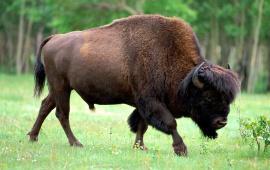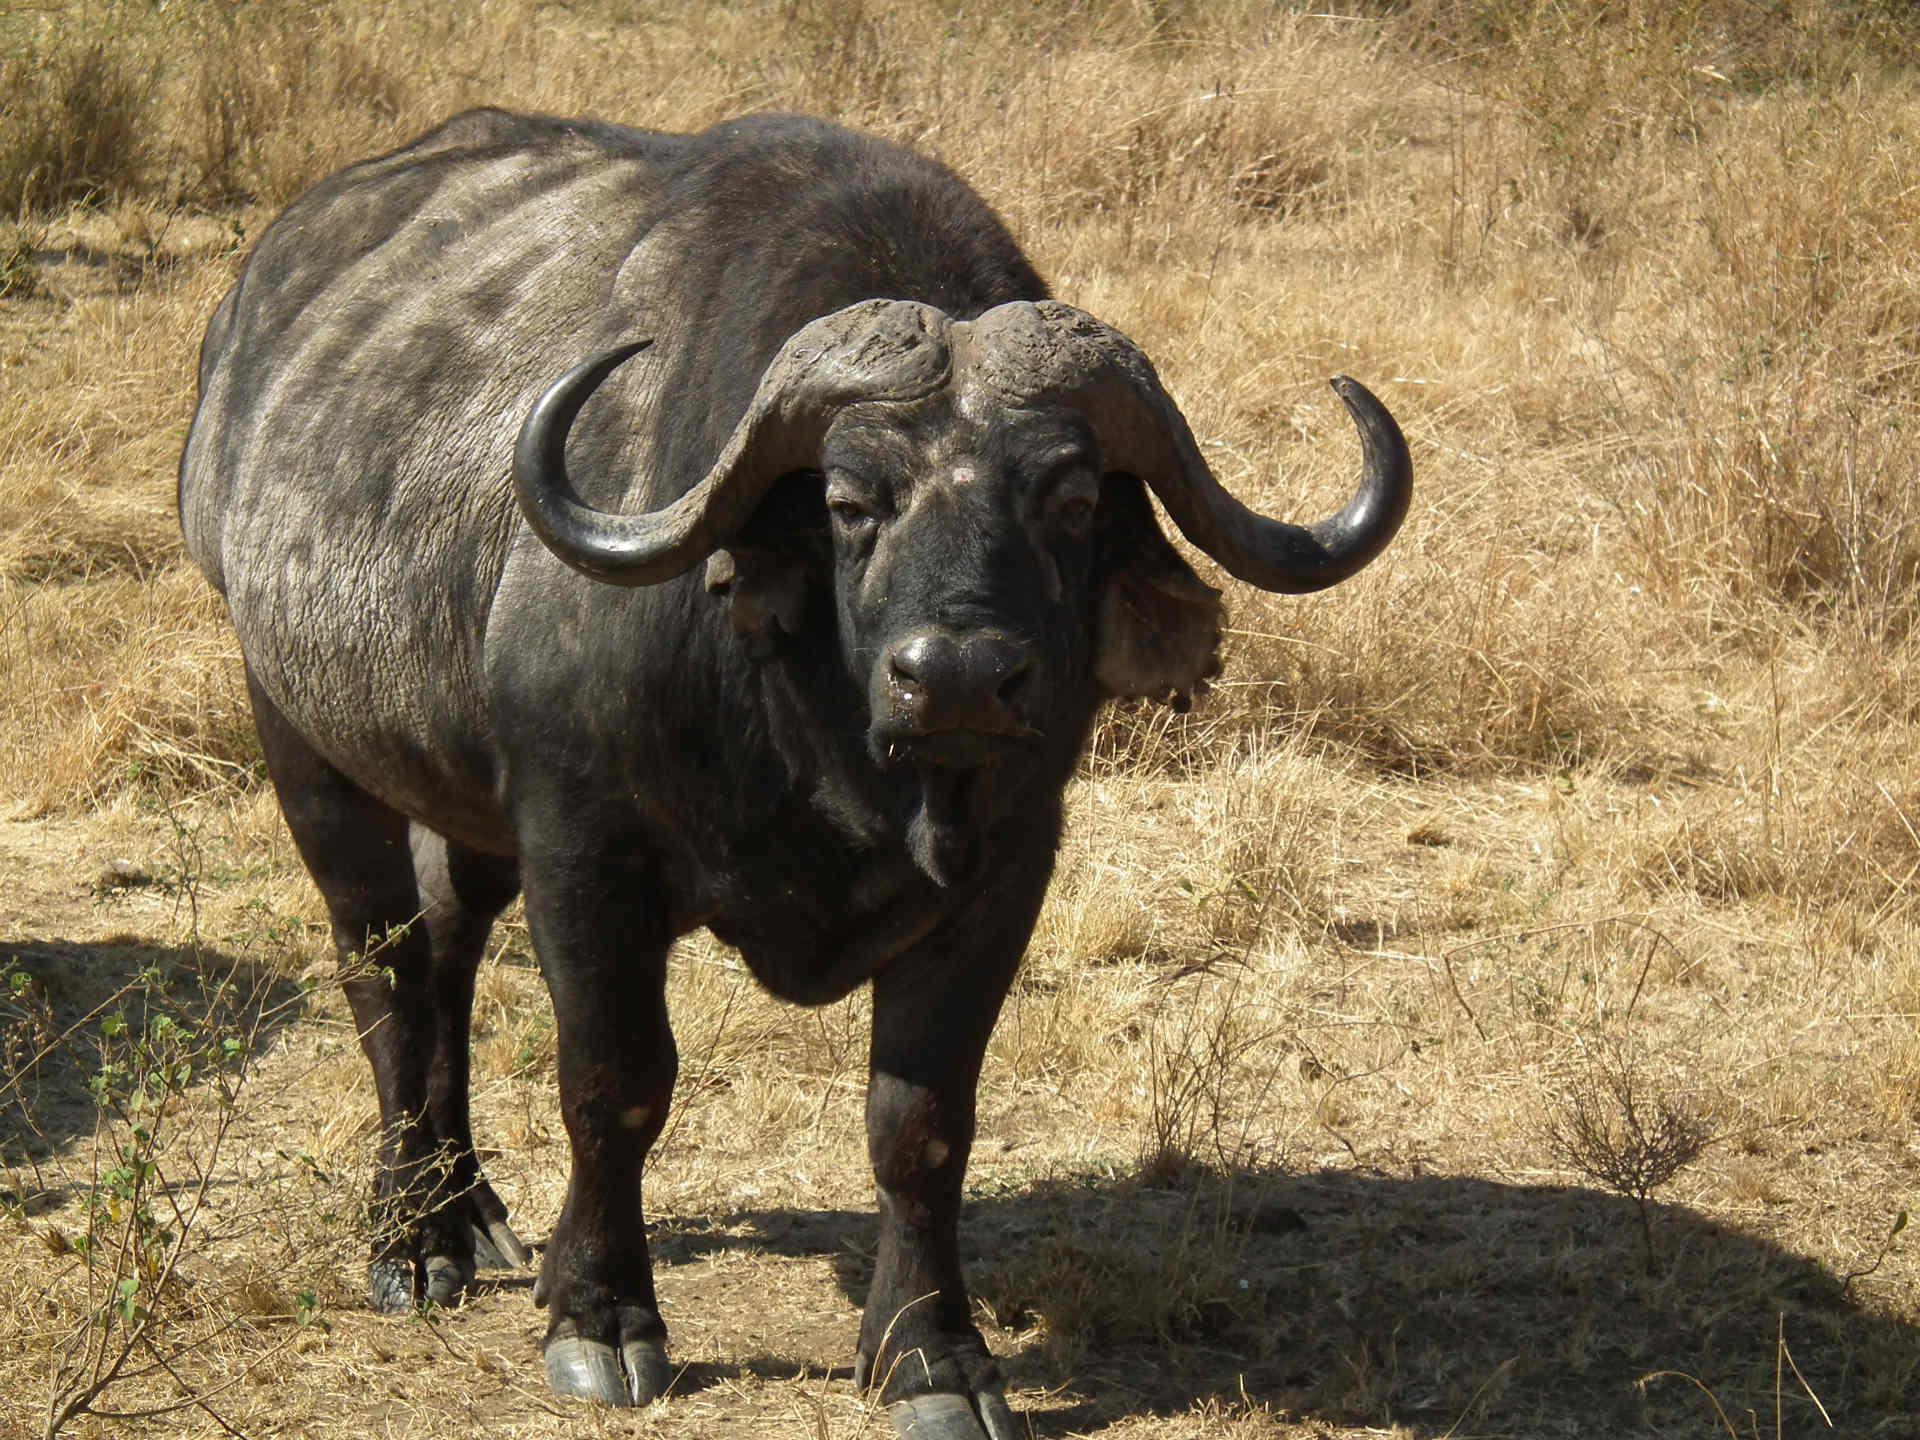The first image is the image on the left, the second image is the image on the right. Considering the images on both sides, is "There are at least two water buffalo's in the right image." valid? Answer yes or no. No. 